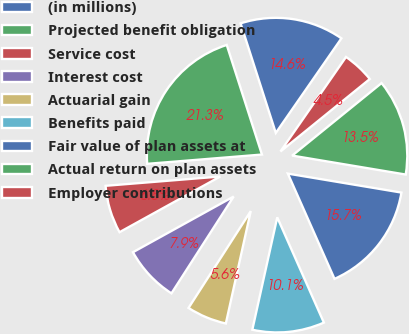Convert chart to OTSL. <chart><loc_0><loc_0><loc_500><loc_500><pie_chart><fcel>(in millions)<fcel>Projected benefit obligation<fcel>Service cost<fcel>Interest cost<fcel>Actuarial gain<fcel>Benefits paid<fcel>Fair value of plan assets at<fcel>Actual return on plan assets<fcel>Employer contributions<nl><fcel>14.6%<fcel>21.34%<fcel>6.75%<fcel>7.87%<fcel>5.62%<fcel>10.11%<fcel>15.73%<fcel>13.48%<fcel>4.5%<nl></chart> 